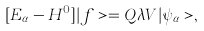Convert formula to latex. <formula><loc_0><loc_0><loc_500><loc_500>[ E _ { \alpha } - H ^ { 0 } ] | f > = Q \lambda V | \psi _ { \alpha } > ,</formula> 